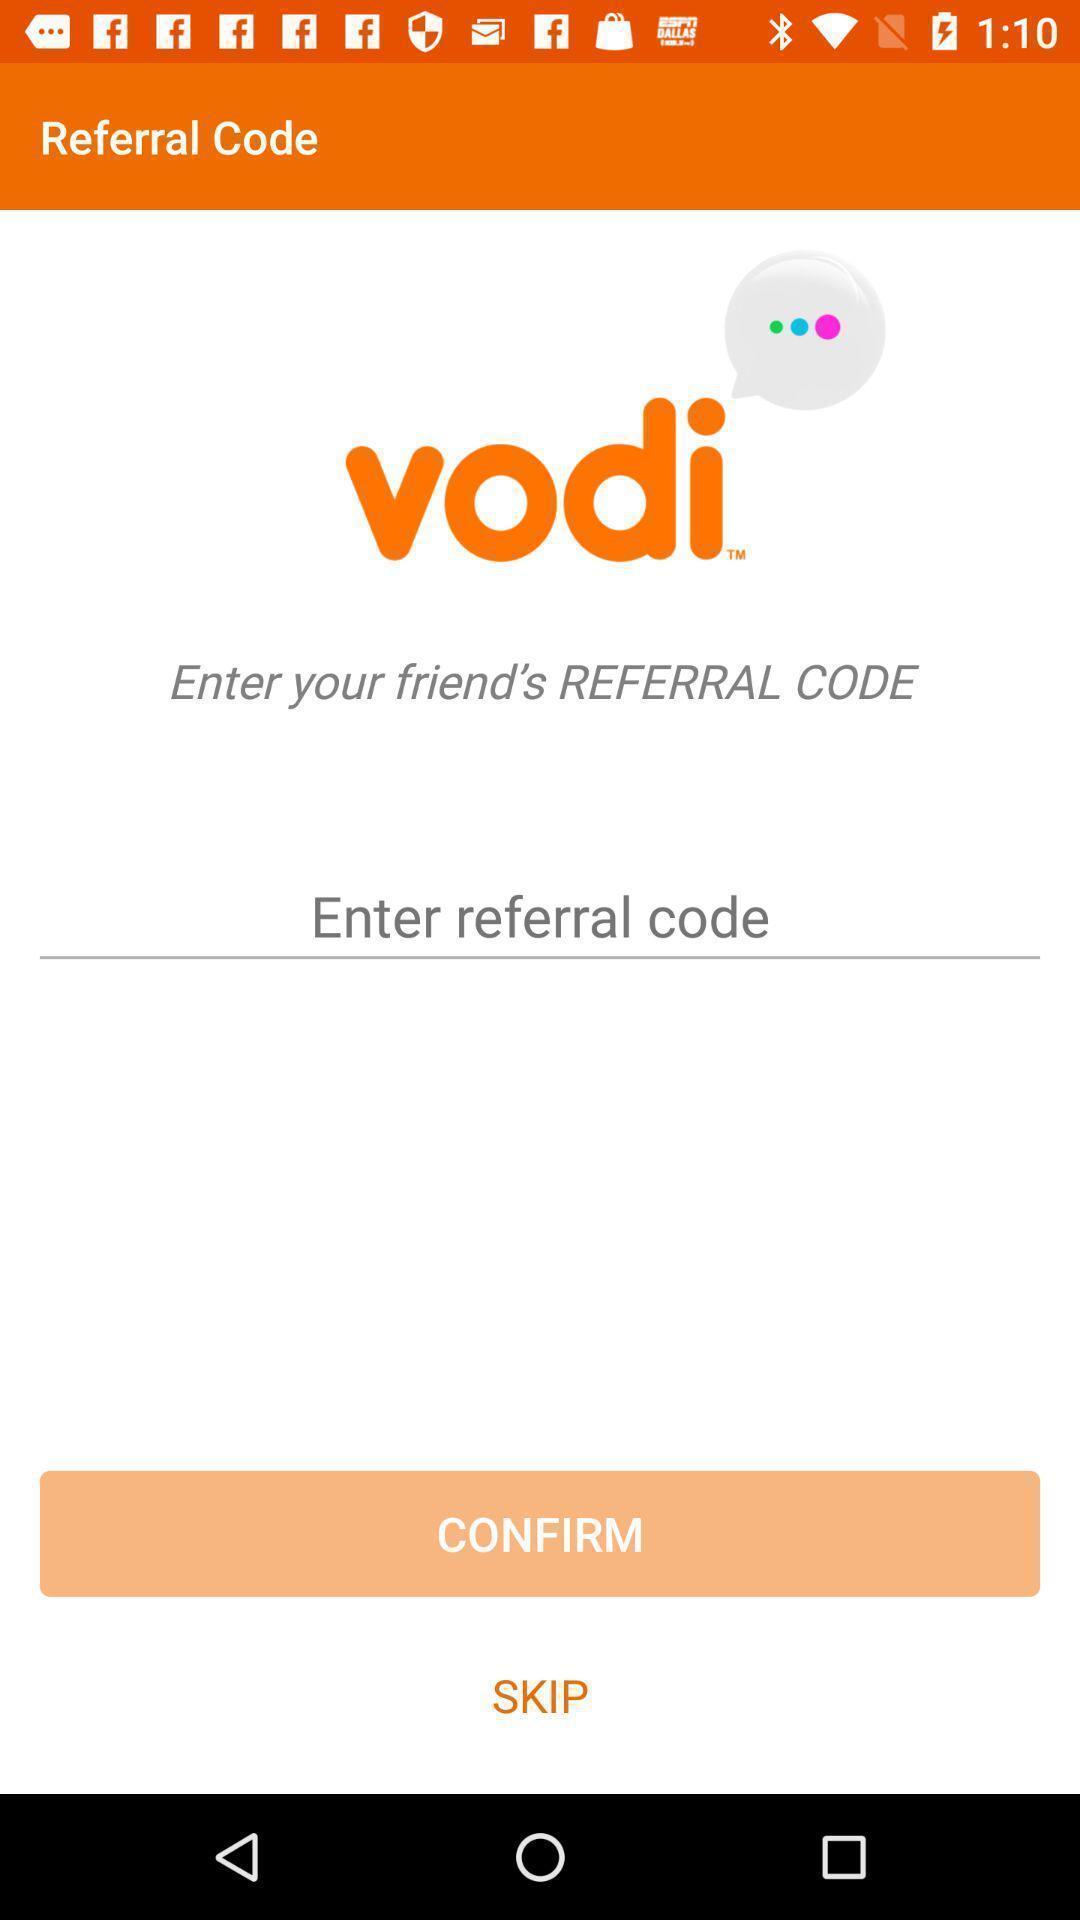What can you discern from this picture? Referral code page. 